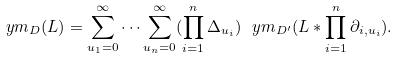<formula> <loc_0><loc_0><loc_500><loc_500>\ y m _ { D } ( L ) = \sum _ { u _ { 1 } = 0 } ^ { \infty } \dots \sum _ { u _ { n } = 0 } ^ { \infty } ( \prod _ { i = 1 } ^ { n } \Delta _ { u _ { i } } ) \ y m _ { D ^ { \prime } } ( L * \prod _ { i = 1 } ^ { n } \partial _ { i , u _ { i } } ) .</formula> 